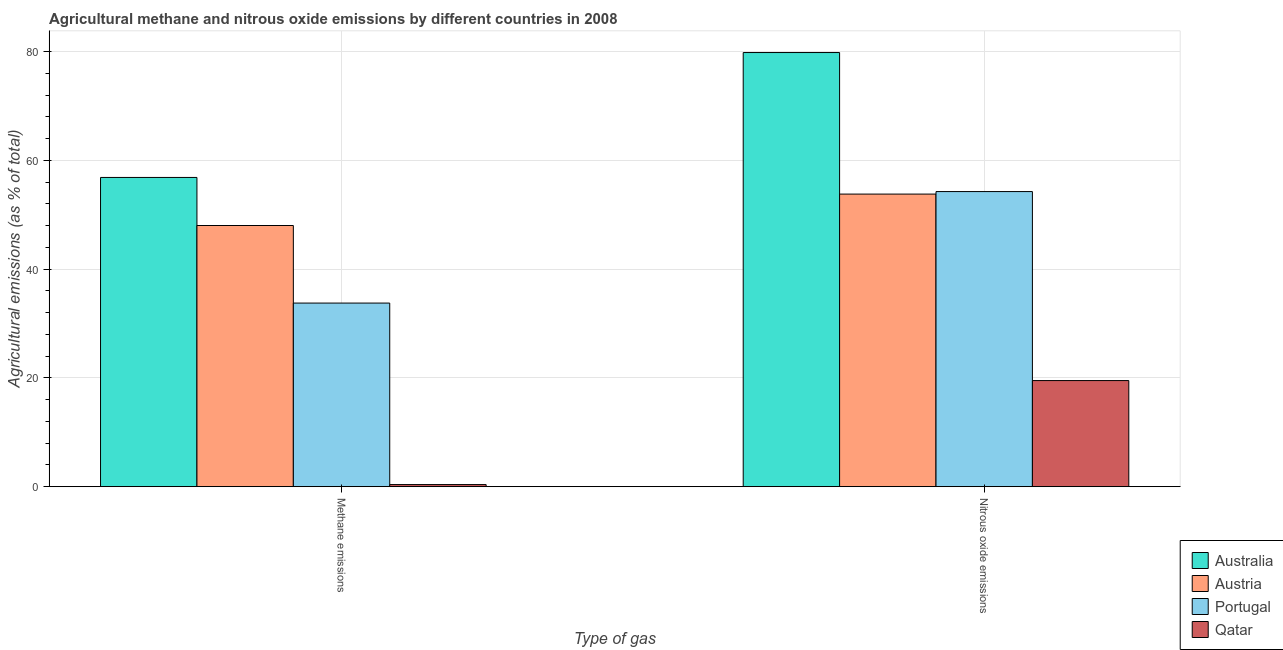How many groups of bars are there?
Provide a short and direct response. 2. How many bars are there on the 2nd tick from the right?
Provide a succinct answer. 4. What is the label of the 1st group of bars from the left?
Your response must be concise. Methane emissions. What is the amount of nitrous oxide emissions in Portugal?
Provide a succinct answer. 54.26. Across all countries, what is the maximum amount of nitrous oxide emissions?
Provide a succinct answer. 79.82. Across all countries, what is the minimum amount of methane emissions?
Provide a succinct answer. 0.39. In which country was the amount of nitrous oxide emissions minimum?
Your response must be concise. Qatar. What is the total amount of methane emissions in the graph?
Offer a very short reply. 139.02. What is the difference between the amount of methane emissions in Austria and that in Qatar?
Offer a terse response. 47.63. What is the difference between the amount of nitrous oxide emissions in Australia and the amount of methane emissions in Austria?
Make the answer very short. 31.8. What is the average amount of nitrous oxide emissions per country?
Ensure brevity in your answer.  51.85. What is the difference between the amount of methane emissions and amount of nitrous oxide emissions in Portugal?
Keep it short and to the point. -20.5. In how many countries, is the amount of nitrous oxide emissions greater than 40 %?
Provide a succinct answer. 3. What is the ratio of the amount of methane emissions in Qatar to that in Austria?
Offer a very short reply. 0.01. Is the amount of nitrous oxide emissions in Austria less than that in Australia?
Give a very brief answer. Yes. In how many countries, is the amount of methane emissions greater than the average amount of methane emissions taken over all countries?
Give a very brief answer. 2. What does the 3rd bar from the left in Nitrous oxide emissions represents?
Give a very brief answer. Portugal. How many bars are there?
Your answer should be compact. 8. How many countries are there in the graph?
Your answer should be compact. 4. What is the difference between two consecutive major ticks on the Y-axis?
Provide a short and direct response. 20. Are the values on the major ticks of Y-axis written in scientific E-notation?
Give a very brief answer. No. Does the graph contain grids?
Make the answer very short. Yes. Where does the legend appear in the graph?
Make the answer very short. Bottom right. What is the title of the graph?
Your answer should be compact. Agricultural methane and nitrous oxide emissions by different countries in 2008. Does "Iran" appear as one of the legend labels in the graph?
Keep it short and to the point. No. What is the label or title of the X-axis?
Ensure brevity in your answer.  Type of gas. What is the label or title of the Y-axis?
Give a very brief answer. Agricultural emissions (as % of total). What is the Agricultural emissions (as % of total) of Australia in Methane emissions?
Offer a terse response. 56.85. What is the Agricultural emissions (as % of total) in Austria in Methane emissions?
Provide a short and direct response. 48.02. What is the Agricultural emissions (as % of total) of Portugal in Methane emissions?
Your response must be concise. 33.76. What is the Agricultural emissions (as % of total) of Qatar in Methane emissions?
Your response must be concise. 0.39. What is the Agricultural emissions (as % of total) of Australia in Nitrous oxide emissions?
Your answer should be compact. 79.82. What is the Agricultural emissions (as % of total) of Austria in Nitrous oxide emissions?
Provide a short and direct response. 53.8. What is the Agricultural emissions (as % of total) in Portugal in Nitrous oxide emissions?
Make the answer very short. 54.26. What is the Agricultural emissions (as % of total) of Qatar in Nitrous oxide emissions?
Give a very brief answer. 19.51. Across all Type of gas, what is the maximum Agricultural emissions (as % of total) in Australia?
Your answer should be compact. 79.82. Across all Type of gas, what is the maximum Agricultural emissions (as % of total) in Austria?
Your answer should be very brief. 53.8. Across all Type of gas, what is the maximum Agricultural emissions (as % of total) in Portugal?
Your answer should be compact. 54.26. Across all Type of gas, what is the maximum Agricultural emissions (as % of total) in Qatar?
Your answer should be very brief. 19.51. Across all Type of gas, what is the minimum Agricultural emissions (as % of total) of Australia?
Your answer should be very brief. 56.85. Across all Type of gas, what is the minimum Agricultural emissions (as % of total) of Austria?
Provide a short and direct response. 48.02. Across all Type of gas, what is the minimum Agricultural emissions (as % of total) in Portugal?
Offer a terse response. 33.76. Across all Type of gas, what is the minimum Agricultural emissions (as % of total) in Qatar?
Provide a succinct answer. 0.39. What is the total Agricultural emissions (as % of total) of Australia in the graph?
Offer a terse response. 136.67. What is the total Agricultural emissions (as % of total) of Austria in the graph?
Your response must be concise. 101.81. What is the total Agricultural emissions (as % of total) in Portugal in the graph?
Offer a terse response. 88.02. What is the total Agricultural emissions (as % of total) in Qatar in the graph?
Offer a terse response. 19.9. What is the difference between the Agricultural emissions (as % of total) in Australia in Methane emissions and that in Nitrous oxide emissions?
Offer a terse response. -22.96. What is the difference between the Agricultural emissions (as % of total) of Austria in Methane emissions and that in Nitrous oxide emissions?
Your answer should be very brief. -5.78. What is the difference between the Agricultural emissions (as % of total) in Portugal in Methane emissions and that in Nitrous oxide emissions?
Your answer should be very brief. -20.5. What is the difference between the Agricultural emissions (as % of total) in Qatar in Methane emissions and that in Nitrous oxide emissions?
Offer a very short reply. -19.12. What is the difference between the Agricultural emissions (as % of total) of Australia in Methane emissions and the Agricultural emissions (as % of total) of Austria in Nitrous oxide emissions?
Offer a terse response. 3.06. What is the difference between the Agricultural emissions (as % of total) in Australia in Methane emissions and the Agricultural emissions (as % of total) in Portugal in Nitrous oxide emissions?
Provide a succinct answer. 2.6. What is the difference between the Agricultural emissions (as % of total) in Australia in Methane emissions and the Agricultural emissions (as % of total) in Qatar in Nitrous oxide emissions?
Give a very brief answer. 37.34. What is the difference between the Agricultural emissions (as % of total) in Austria in Methane emissions and the Agricultural emissions (as % of total) in Portugal in Nitrous oxide emissions?
Your answer should be very brief. -6.24. What is the difference between the Agricultural emissions (as % of total) of Austria in Methane emissions and the Agricultural emissions (as % of total) of Qatar in Nitrous oxide emissions?
Your answer should be compact. 28.51. What is the difference between the Agricultural emissions (as % of total) in Portugal in Methane emissions and the Agricultural emissions (as % of total) in Qatar in Nitrous oxide emissions?
Your answer should be very brief. 14.25. What is the average Agricultural emissions (as % of total) in Australia per Type of gas?
Offer a terse response. 68.34. What is the average Agricultural emissions (as % of total) in Austria per Type of gas?
Offer a very short reply. 50.91. What is the average Agricultural emissions (as % of total) in Portugal per Type of gas?
Make the answer very short. 44.01. What is the average Agricultural emissions (as % of total) of Qatar per Type of gas?
Offer a very short reply. 9.95. What is the difference between the Agricultural emissions (as % of total) in Australia and Agricultural emissions (as % of total) in Austria in Methane emissions?
Your response must be concise. 8.84. What is the difference between the Agricultural emissions (as % of total) in Australia and Agricultural emissions (as % of total) in Portugal in Methane emissions?
Ensure brevity in your answer.  23.1. What is the difference between the Agricultural emissions (as % of total) of Australia and Agricultural emissions (as % of total) of Qatar in Methane emissions?
Ensure brevity in your answer.  56.47. What is the difference between the Agricultural emissions (as % of total) of Austria and Agricultural emissions (as % of total) of Portugal in Methane emissions?
Give a very brief answer. 14.26. What is the difference between the Agricultural emissions (as % of total) in Austria and Agricultural emissions (as % of total) in Qatar in Methane emissions?
Your response must be concise. 47.63. What is the difference between the Agricultural emissions (as % of total) in Portugal and Agricultural emissions (as % of total) in Qatar in Methane emissions?
Your answer should be compact. 33.37. What is the difference between the Agricultural emissions (as % of total) in Australia and Agricultural emissions (as % of total) in Austria in Nitrous oxide emissions?
Offer a terse response. 26.02. What is the difference between the Agricultural emissions (as % of total) of Australia and Agricultural emissions (as % of total) of Portugal in Nitrous oxide emissions?
Give a very brief answer. 25.56. What is the difference between the Agricultural emissions (as % of total) of Australia and Agricultural emissions (as % of total) of Qatar in Nitrous oxide emissions?
Provide a short and direct response. 60.31. What is the difference between the Agricultural emissions (as % of total) in Austria and Agricultural emissions (as % of total) in Portugal in Nitrous oxide emissions?
Offer a very short reply. -0.46. What is the difference between the Agricultural emissions (as % of total) of Austria and Agricultural emissions (as % of total) of Qatar in Nitrous oxide emissions?
Ensure brevity in your answer.  34.28. What is the difference between the Agricultural emissions (as % of total) of Portugal and Agricultural emissions (as % of total) of Qatar in Nitrous oxide emissions?
Your answer should be compact. 34.75. What is the ratio of the Agricultural emissions (as % of total) of Australia in Methane emissions to that in Nitrous oxide emissions?
Your answer should be very brief. 0.71. What is the ratio of the Agricultural emissions (as % of total) of Austria in Methane emissions to that in Nitrous oxide emissions?
Keep it short and to the point. 0.89. What is the ratio of the Agricultural emissions (as % of total) of Portugal in Methane emissions to that in Nitrous oxide emissions?
Provide a succinct answer. 0.62. What is the difference between the highest and the second highest Agricultural emissions (as % of total) of Australia?
Your response must be concise. 22.96. What is the difference between the highest and the second highest Agricultural emissions (as % of total) in Austria?
Offer a terse response. 5.78. What is the difference between the highest and the second highest Agricultural emissions (as % of total) of Portugal?
Your response must be concise. 20.5. What is the difference between the highest and the second highest Agricultural emissions (as % of total) in Qatar?
Provide a short and direct response. 19.12. What is the difference between the highest and the lowest Agricultural emissions (as % of total) of Australia?
Keep it short and to the point. 22.96. What is the difference between the highest and the lowest Agricultural emissions (as % of total) of Austria?
Your answer should be compact. 5.78. What is the difference between the highest and the lowest Agricultural emissions (as % of total) of Portugal?
Keep it short and to the point. 20.5. What is the difference between the highest and the lowest Agricultural emissions (as % of total) in Qatar?
Offer a very short reply. 19.12. 